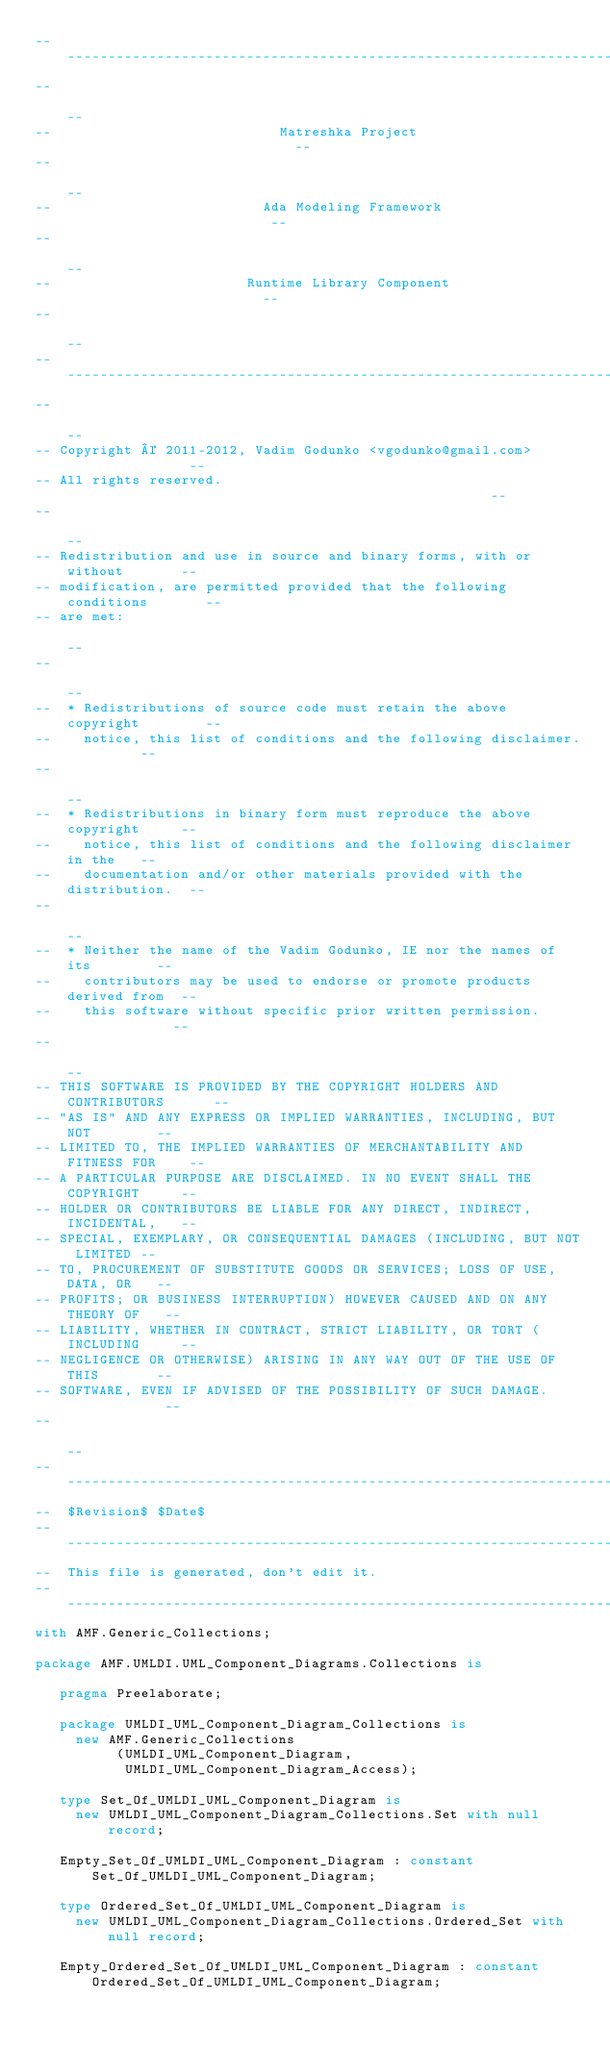<code> <loc_0><loc_0><loc_500><loc_500><_Ada_>------------------------------------------------------------------------------
--                                                                          --
--                            Matreshka Project                             --
--                                                                          --
--                          Ada Modeling Framework                          --
--                                                                          --
--                        Runtime Library Component                         --
--                                                                          --
------------------------------------------------------------------------------
--                                                                          --
-- Copyright © 2011-2012, Vadim Godunko <vgodunko@gmail.com>                --
-- All rights reserved.                                                     --
--                                                                          --
-- Redistribution and use in source and binary forms, with or without       --
-- modification, are permitted provided that the following conditions       --
-- are met:                                                                 --
--                                                                          --
--  * Redistributions of source code must retain the above copyright        --
--    notice, this list of conditions and the following disclaimer.         --
--                                                                          --
--  * Redistributions in binary form must reproduce the above copyright     --
--    notice, this list of conditions and the following disclaimer in the   --
--    documentation and/or other materials provided with the distribution.  --
--                                                                          --
--  * Neither the name of the Vadim Godunko, IE nor the names of its        --
--    contributors may be used to endorse or promote products derived from  --
--    this software without specific prior written permission.              --
--                                                                          --
-- THIS SOFTWARE IS PROVIDED BY THE COPYRIGHT HOLDERS AND CONTRIBUTORS      --
-- "AS IS" AND ANY EXPRESS OR IMPLIED WARRANTIES, INCLUDING, BUT NOT        --
-- LIMITED TO, THE IMPLIED WARRANTIES OF MERCHANTABILITY AND FITNESS FOR    --
-- A PARTICULAR PURPOSE ARE DISCLAIMED. IN NO EVENT SHALL THE COPYRIGHT     --
-- HOLDER OR CONTRIBUTORS BE LIABLE FOR ANY DIRECT, INDIRECT, INCIDENTAL,   --
-- SPECIAL, EXEMPLARY, OR CONSEQUENTIAL DAMAGES (INCLUDING, BUT NOT LIMITED --
-- TO, PROCUREMENT OF SUBSTITUTE GOODS OR SERVICES; LOSS OF USE, DATA, OR   --
-- PROFITS; OR BUSINESS INTERRUPTION) HOWEVER CAUSED AND ON ANY THEORY OF   --
-- LIABILITY, WHETHER IN CONTRACT, STRICT LIABILITY, OR TORT (INCLUDING     --
-- NEGLIGENCE OR OTHERWISE) ARISING IN ANY WAY OUT OF THE USE OF THIS       --
-- SOFTWARE, EVEN IF ADVISED OF THE POSSIBILITY OF SUCH DAMAGE.             --
--                                                                          --
------------------------------------------------------------------------------
--  $Revision$ $Date$
------------------------------------------------------------------------------
--  This file is generated, don't edit it.
------------------------------------------------------------------------------
with AMF.Generic_Collections;

package AMF.UMLDI.UML_Component_Diagrams.Collections is

   pragma Preelaborate;

   package UMLDI_UML_Component_Diagram_Collections is
     new AMF.Generic_Collections
          (UMLDI_UML_Component_Diagram,
           UMLDI_UML_Component_Diagram_Access);

   type Set_Of_UMLDI_UML_Component_Diagram is
     new UMLDI_UML_Component_Diagram_Collections.Set with null record;

   Empty_Set_Of_UMLDI_UML_Component_Diagram : constant Set_Of_UMLDI_UML_Component_Diagram;

   type Ordered_Set_Of_UMLDI_UML_Component_Diagram is
     new UMLDI_UML_Component_Diagram_Collections.Ordered_Set with null record;

   Empty_Ordered_Set_Of_UMLDI_UML_Component_Diagram : constant Ordered_Set_Of_UMLDI_UML_Component_Diagram;
</code> 